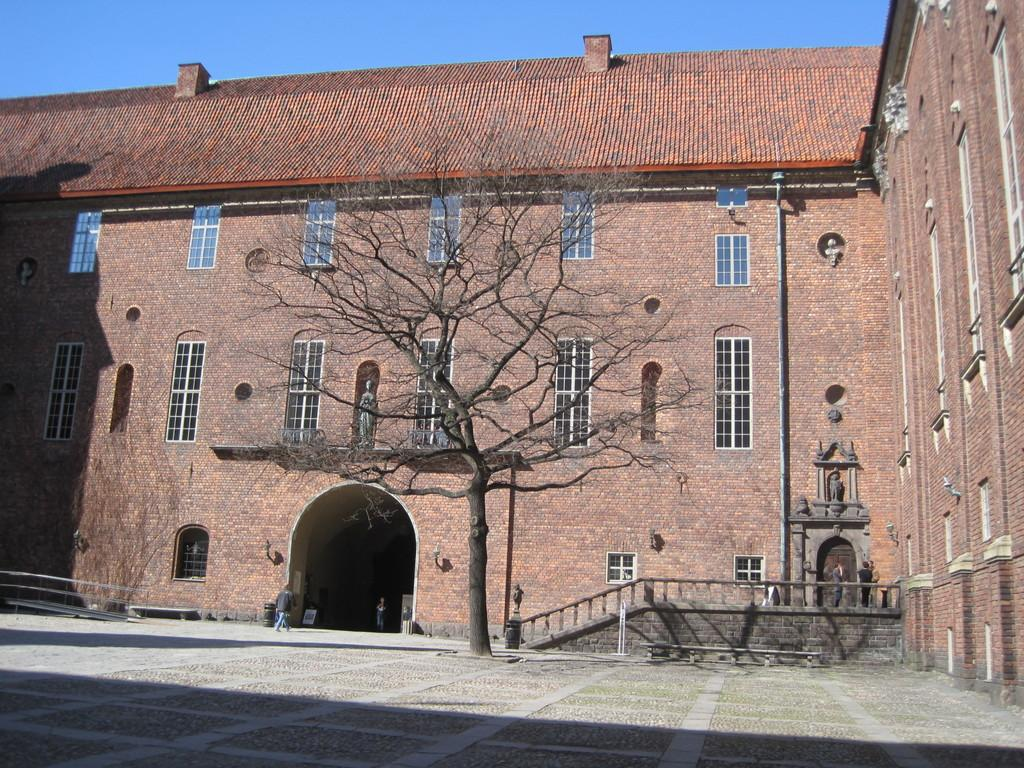What is the man in the image doing? There is a man walking in the image. What type of structure can be seen in the image? There is a building in the image. What natural element is present in the image? There is a tree in the image. What architectural feature can be seen on the building? There are windows in the image. What artistic objects are present in the image? There are statues in the image. What can be seen in the background of the image? The sky is visible in the background of the image, and it is blue in color. Where is the canvas located in the image? There is no canvas present in the image. Is the man walking on quicksand in the image? No, the man is walking on a solid surface, not quicksand, as there is no indication of quicksand in the image. 